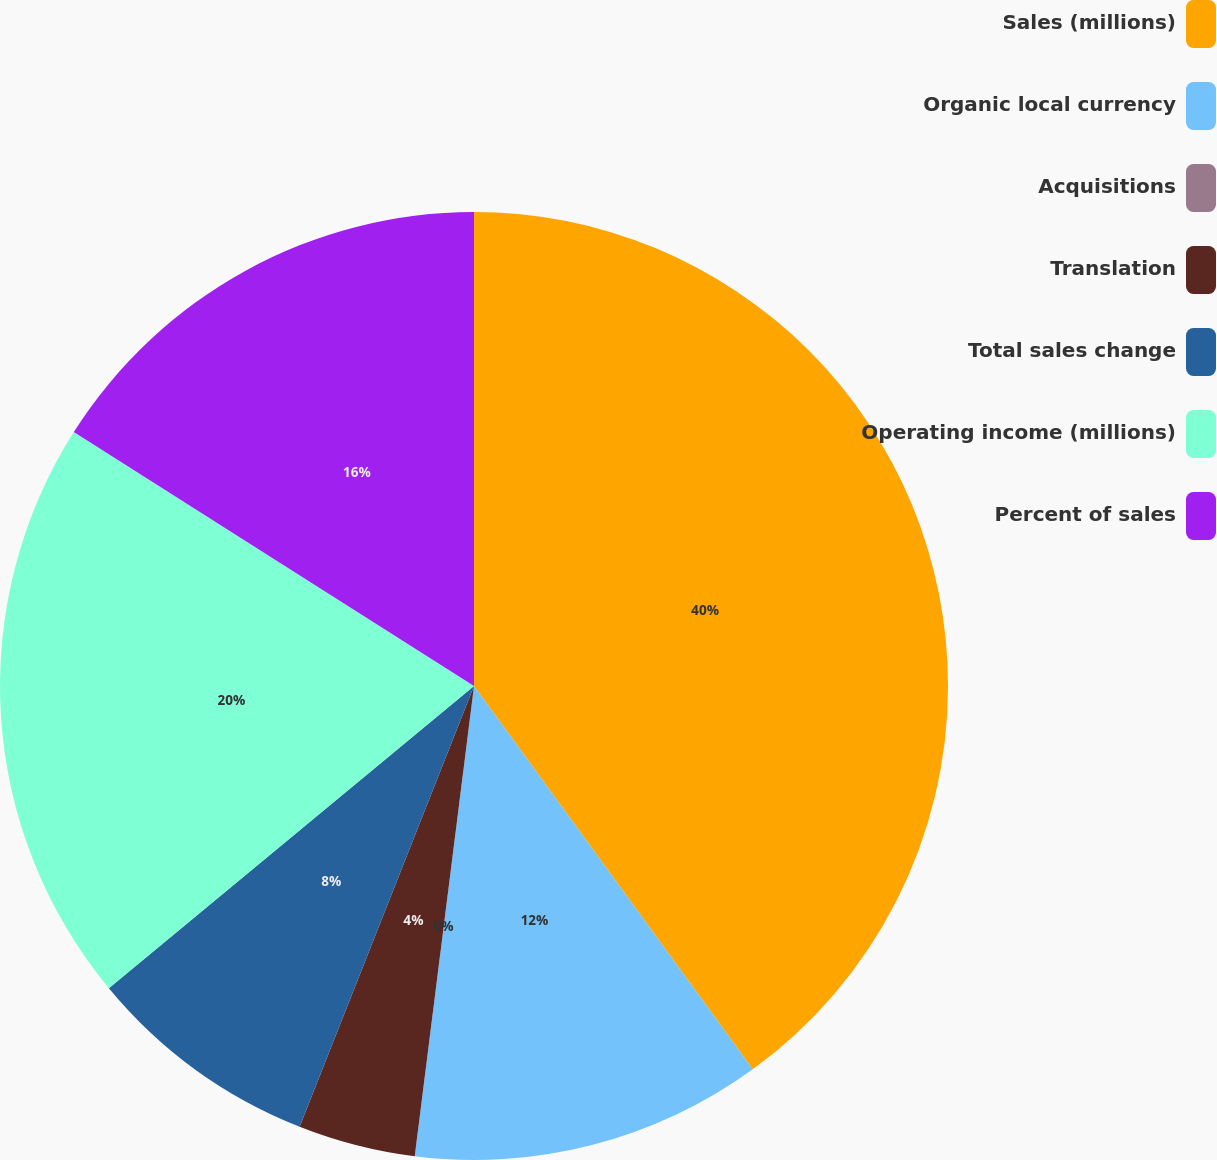<chart> <loc_0><loc_0><loc_500><loc_500><pie_chart><fcel>Sales (millions)<fcel>Organic local currency<fcel>Acquisitions<fcel>Translation<fcel>Total sales change<fcel>Operating income (millions)<fcel>Percent of sales<nl><fcel>39.99%<fcel>12.0%<fcel>0.0%<fcel>4.0%<fcel>8.0%<fcel>20.0%<fcel>16.0%<nl></chart> 